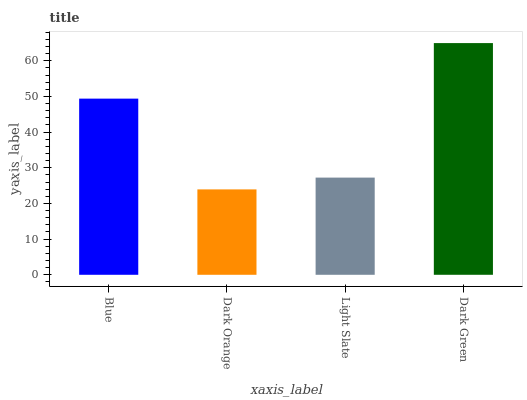Is Dark Orange the minimum?
Answer yes or no. Yes. Is Dark Green the maximum?
Answer yes or no. Yes. Is Light Slate the minimum?
Answer yes or no. No. Is Light Slate the maximum?
Answer yes or no. No. Is Light Slate greater than Dark Orange?
Answer yes or no. Yes. Is Dark Orange less than Light Slate?
Answer yes or no. Yes. Is Dark Orange greater than Light Slate?
Answer yes or no. No. Is Light Slate less than Dark Orange?
Answer yes or no. No. Is Blue the high median?
Answer yes or no. Yes. Is Light Slate the low median?
Answer yes or no. Yes. Is Dark Orange the high median?
Answer yes or no. No. Is Blue the low median?
Answer yes or no. No. 